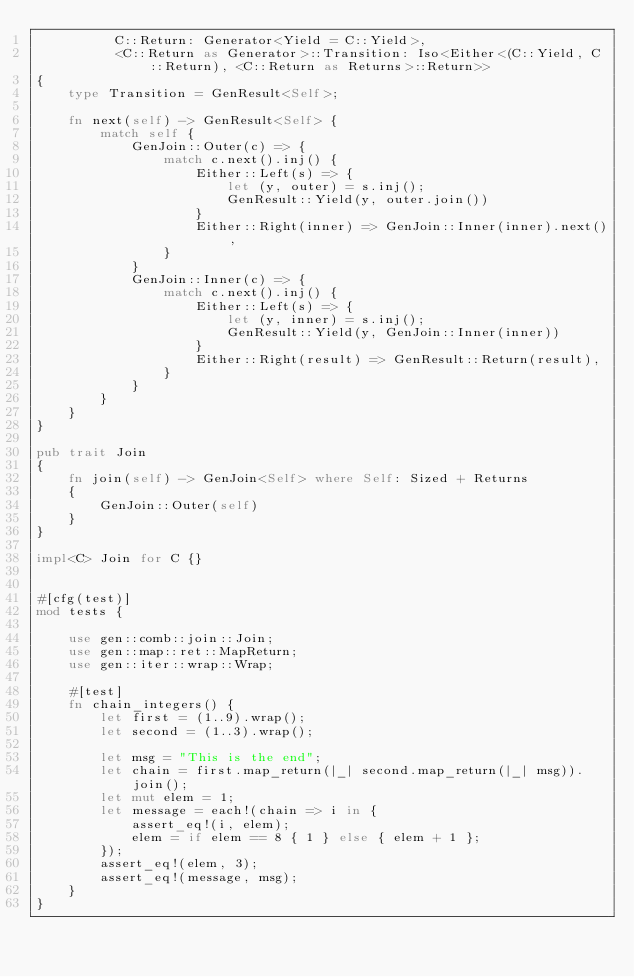<code> <loc_0><loc_0><loc_500><loc_500><_Rust_>          C::Return: Generator<Yield = C::Yield>,
          <C::Return as Generator>::Transition: Iso<Either<(C::Yield, C::Return), <C::Return as Returns>::Return>>
{
    type Transition = GenResult<Self>;

    fn next(self) -> GenResult<Self> {
        match self {
            GenJoin::Outer(c) => {
                match c.next().inj() {
                    Either::Left(s) => {
                        let (y, outer) = s.inj();
                        GenResult::Yield(y, outer.join())
                    }
                    Either::Right(inner) => GenJoin::Inner(inner).next(),
                }
            }
            GenJoin::Inner(c) => {
                match c.next().inj() {
                    Either::Left(s) => {
                        let (y, inner) = s.inj();
                        GenResult::Yield(y, GenJoin::Inner(inner))
                    }
                    Either::Right(result) => GenResult::Return(result),
                }
            }
        }
    }
}

pub trait Join
{
    fn join(self) -> GenJoin<Self> where Self: Sized + Returns
    {
        GenJoin::Outer(self)
    }
}

impl<C> Join for C {}


#[cfg(test)]
mod tests {

    use gen::comb::join::Join;
    use gen::map::ret::MapReturn;
    use gen::iter::wrap::Wrap;

    #[test]
    fn chain_integers() {
        let first = (1..9).wrap();
        let second = (1..3).wrap();

        let msg = "This is the end";
        let chain = first.map_return(|_| second.map_return(|_| msg)).join();
        let mut elem = 1;
        let message = each!(chain => i in {
            assert_eq!(i, elem);
            elem = if elem == 8 { 1 } else { elem + 1 };
        });
        assert_eq!(elem, 3);
        assert_eq!(message, msg);
    }
}
</code> 